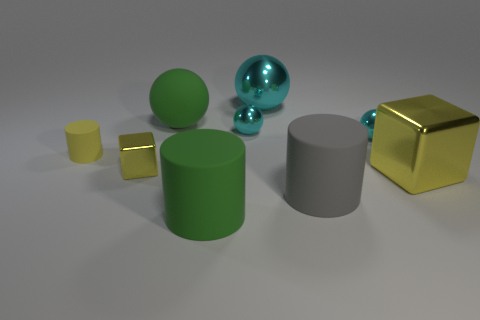Subtract all cyan blocks. How many cyan spheres are left? 3 Subtract all green spheres. How many spheres are left? 3 Subtract all big green rubber spheres. How many spheres are left? 3 Subtract 1 spheres. How many spheres are left? 3 Subtract all red spheres. Subtract all purple blocks. How many spheres are left? 4 Subtract all cylinders. How many objects are left? 6 Add 8 gray rubber cylinders. How many gray rubber cylinders exist? 9 Subtract 1 green cylinders. How many objects are left? 8 Subtract all green things. Subtract all small metal spheres. How many objects are left? 5 Add 8 large gray things. How many large gray things are left? 9 